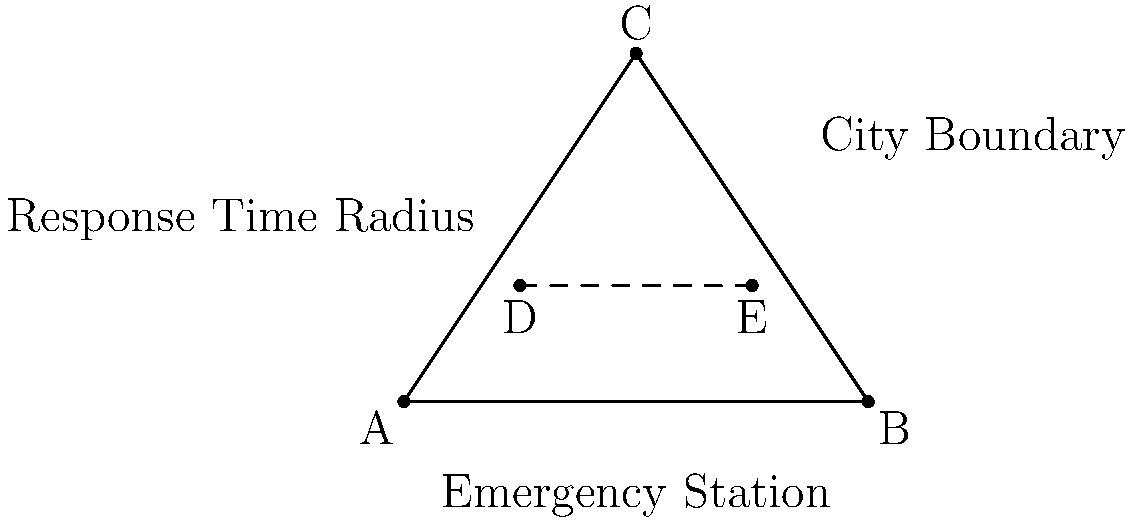Given the triangular city layout shown, where emergency stations are placed along the base (AB) of the triangle, what is the optimal number and placement of stations to ensure that every point within the city is within a radius r from at least one station, while minimizing the number of stations required? To solve this problem, we need to follow these steps:

1. Recognize that the problem is equivalent to covering the triangle with circles of radius r.

2. The optimal placement of stations will be along the base of the triangle (AB) to maximize coverage.

3. The number of stations needed depends on the length of AB and the radius r:
   
   $$ \text{Number of stations} = \left\lceil\frac{|AB|}{2r}\right\rceil $$

   Where $\lceil x \rceil$ denotes the ceiling function (smallest integer greater than or equal to x).

4. The optimal placement of stations will be evenly spaced along AB, with the first and last stations placed r distance from A and B respectively.

5. If n is the number of stations, the distance between each station will be:

   $$ \text{Distance between stations} = \frac{|AB| - 2r}{n-1} $$

6. The exact coordinates of each station can be calculated using this distance.

7. To ensure complete coverage, we need to check if the height of the triangle (distance from C to AB) is less than or equal to r. If not, additional stations may be needed along the height of the triangle.
Answer: $\left\lceil\frac{|AB|}{2r}\right\rceil$ stations, evenly spaced along AB 